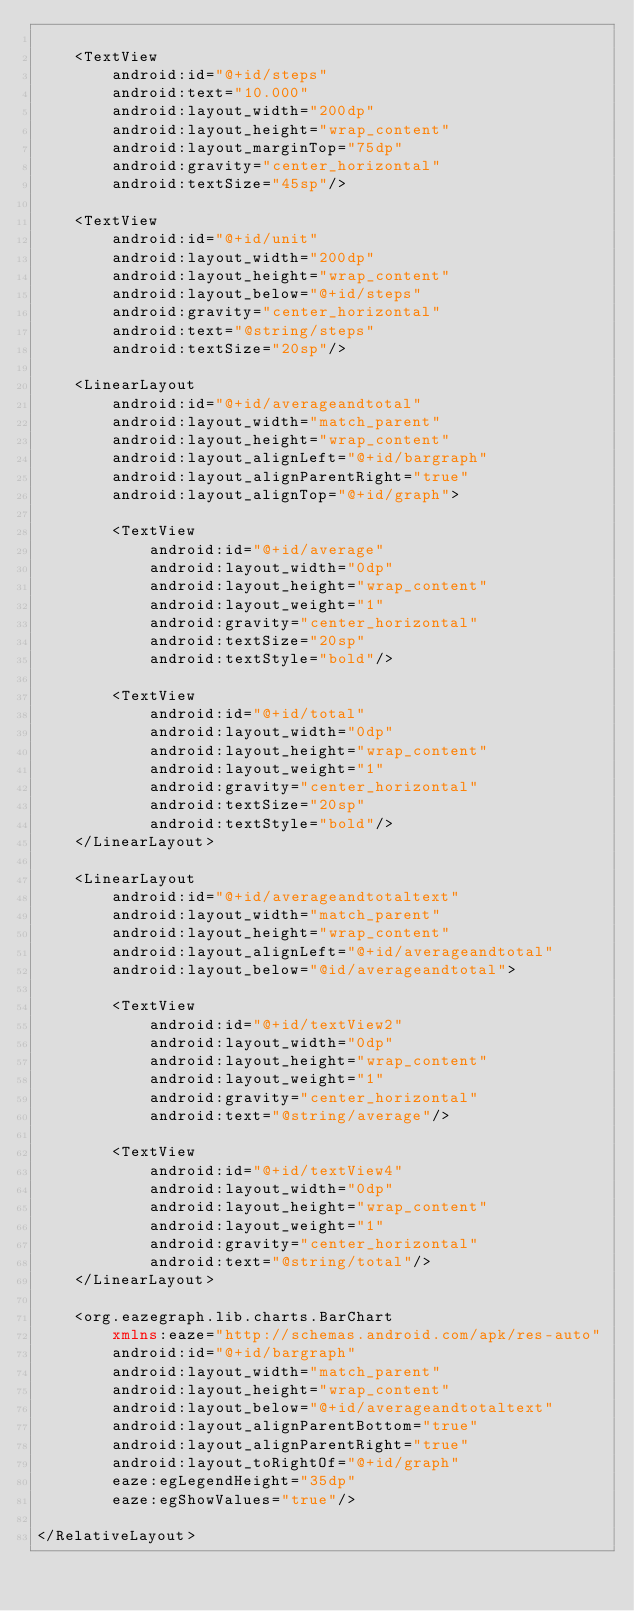Convert code to text. <code><loc_0><loc_0><loc_500><loc_500><_XML_>
    <TextView
        android:id="@+id/steps"
        android:text="10.000"
        android:layout_width="200dp"
        android:layout_height="wrap_content"
        android:layout_marginTop="75dp"
        android:gravity="center_horizontal"
        android:textSize="45sp"/>

    <TextView
        android:id="@+id/unit"
        android:layout_width="200dp"
        android:layout_height="wrap_content"
        android:layout_below="@+id/steps"
        android:gravity="center_horizontal"
        android:text="@string/steps"
        android:textSize="20sp"/>

    <LinearLayout
        android:id="@+id/averageandtotal"
        android:layout_width="match_parent"
        android:layout_height="wrap_content"
        android:layout_alignLeft="@+id/bargraph"
        android:layout_alignParentRight="true"
        android:layout_alignTop="@+id/graph">

        <TextView
            android:id="@+id/average"
            android:layout_width="0dp"
            android:layout_height="wrap_content"
            android:layout_weight="1"
            android:gravity="center_horizontal"
            android:textSize="20sp"
            android:textStyle="bold"/>

        <TextView
            android:id="@+id/total"
            android:layout_width="0dp"
            android:layout_height="wrap_content"
            android:layout_weight="1"
            android:gravity="center_horizontal"
            android:textSize="20sp"
            android:textStyle="bold"/>
    </LinearLayout>

    <LinearLayout
        android:id="@+id/averageandtotaltext"
        android:layout_width="match_parent"
        android:layout_height="wrap_content"
        android:layout_alignLeft="@+id/averageandtotal"
        android:layout_below="@id/averageandtotal">

        <TextView
            android:id="@+id/textView2"
            android:layout_width="0dp"
            android:layout_height="wrap_content"
            android:layout_weight="1"
            android:gravity="center_horizontal"
            android:text="@string/average"/>

        <TextView
            android:id="@+id/textView4"
            android:layout_width="0dp"
            android:layout_height="wrap_content"
            android:layout_weight="1"
            android:gravity="center_horizontal"
            android:text="@string/total"/>
    </LinearLayout>

    <org.eazegraph.lib.charts.BarChart
        xmlns:eaze="http://schemas.android.com/apk/res-auto"
        android:id="@+id/bargraph"
        android:layout_width="match_parent"
        android:layout_height="wrap_content"
        android:layout_below="@+id/averageandtotaltext"
        android:layout_alignParentBottom="true"
        android:layout_alignParentRight="true"
        android:layout_toRightOf="@+id/graph"
        eaze:egLegendHeight="35dp"
        eaze:egShowValues="true"/>

</RelativeLayout></code> 